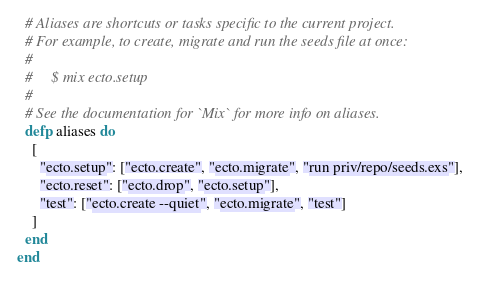<code> <loc_0><loc_0><loc_500><loc_500><_Elixir_>
  # Aliases are shortcuts or tasks specific to the current project.
  # For example, to create, migrate and run the seeds file at once:
  #
  #     $ mix ecto.setup
  #
  # See the documentation for `Mix` for more info on aliases.
  defp aliases do
    [
      "ecto.setup": ["ecto.create", "ecto.migrate", "run priv/repo/seeds.exs"],
      "ecto.reset": ["ecto.drop", "ecto.setup"],
      "test": ["ecto.create --quiet", "ecto.migrate", "test"]
    ]
  end
end
</code> 